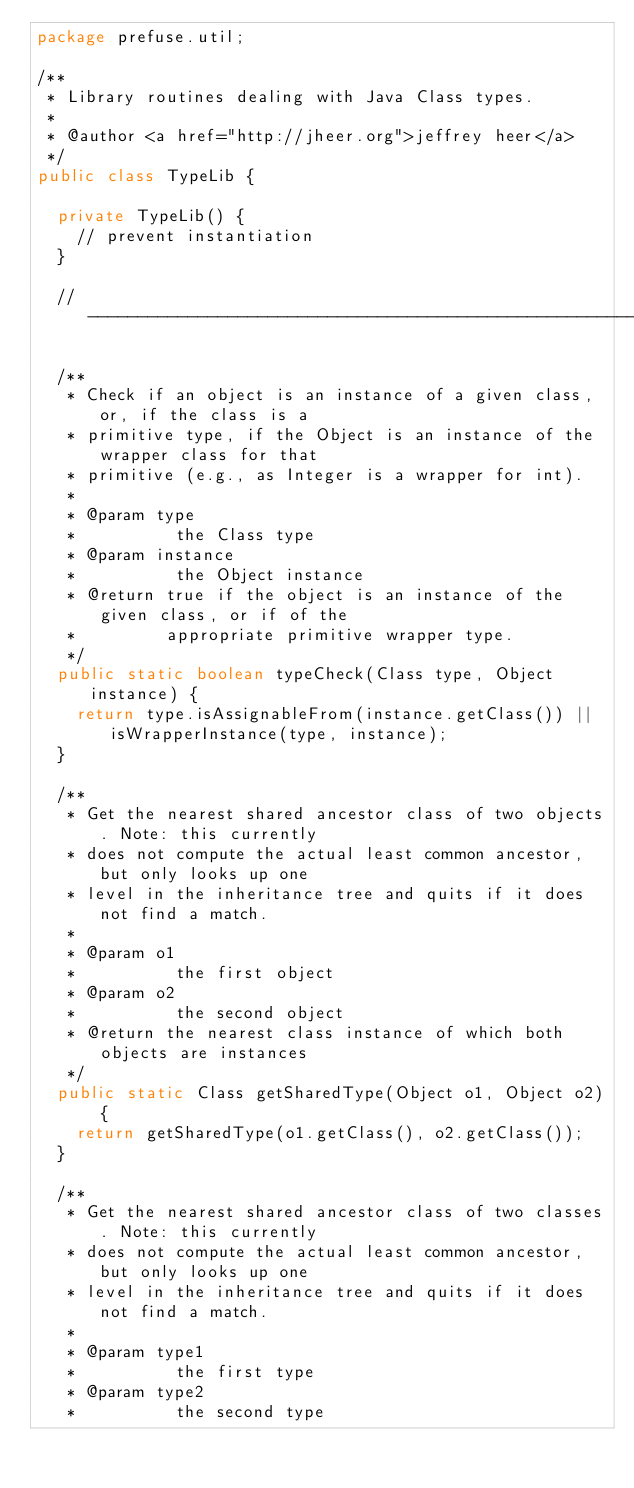Convert code to text. <code><loc_0><loc_0><loc_500><loc_500><_Java_>package prefuse.util;

/**
 * Library routines dealing with Java Class types.
 * 
 * @author <a href="http://jheer.org">jeffrey heer</a>
 */
public class TypeLib {

  private TypeLib() {
    // prevent instantiation
  }

  // ------------------------------------------------------------------------

  /**
   * Check if an object is an instance of a given class, or, if the class is a
   * primitive type, if the Object is an instance of the wrapper class for that
   * primitive (e.g., as Integer is a wrapper for int).
   * 
   * @param type
   *          the Class type
   * @param instance
   *          the Object instance
   * @return true if the object is an instance of the given class, or if of the
   *         appropriate primitive wrapper type.
   */
  public static boolean typeCheck(Class type, Object instance) {
    return type.isAssignableFrom(instance.getClass()) || isWrapperInstance(type, instance);
  }

  /**
   * Get the nearest shared ancestor class of two objects. Note: this currently
   * does not compute the actual least common ancestor, but only looks up one
   * level in the inheritance tree and quits if it does not find a match.
   * 
   * @param o1
   *          the first object
   * @param o2
   *          the second object
   * @return the nearest class instance of which both objects are instances
   */
  public static Class getSharedType(Object o1, Object o2) {
    return getSharedType(o1.getClass(), o2.getClass());
  }

  /**
   * Get the nearest shared ancestor class of two classes. Note: this currently
   * does not compute the actual least common ancestor, but only looks up one
   * level in the inheritance tree and quits if it does not find a match.
   * 
   * @param type1
   *          the first type
   * @param type2
   *          the second type</code> 